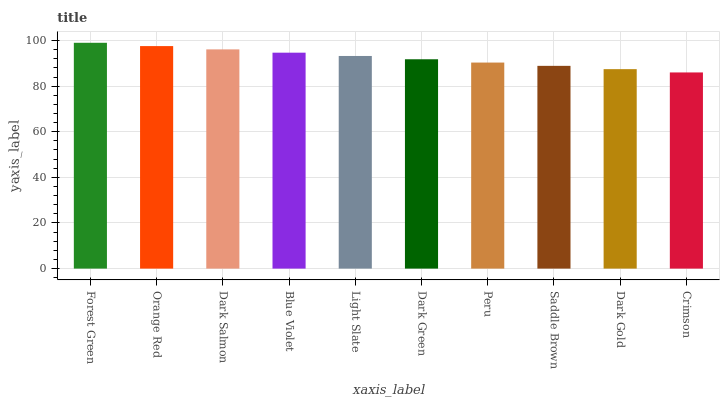Is Crimson the minimum?
Answer yes or no. Yes. Is Forest Green the maximum?
Answer yes or no. Yes. Is Orange Red the minimum?
Answer yes or no. No. Is Orange Red the maximum?
Answer yes or no. No. Is Forest Green greater than Orange Red?
Answer yes or no. Yes. Is Orange Red less than Forest Green?
Answer yes or no. Yes. Is Orange Red greater than Forest Green?
Answer yes or no. No. Is Forest Green less than Orange Red?
Answer yes or no. No. Is Light Slate the high median?
Answer yes or no. Yes. Is Dark Green the low median?
Answer yes or no. Yes. Is Dark Gold the high median?
Answer yes or no. No. Is Forest Green the low median?
Answer yes or no. No. 